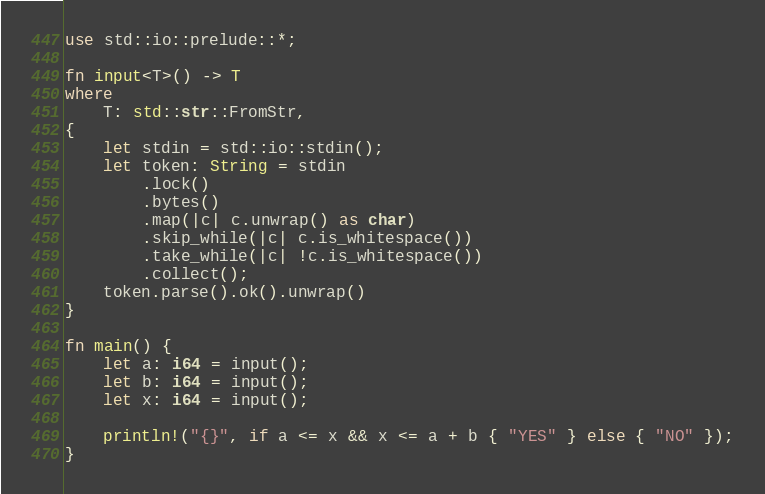<code> <loc_0><loc_0><loc_500><loc_500><_Rust_>use std::io::prelude::*;

fn input<T>() -> T
where
    T: std::str::FromStr,
{
    let stdin = std::io::stdin();
    let token: String = stdin
        .lock()
        .bytes()
        .map(|c| c.unwrap() as char)
        .skip_while(|c| c.is_whitespace())
        .take_while(|c| !c.is_whitespace())
        .collect();
    token.parse().ok().unwrap()
}

fn main() {
    let a: i64 = input();
    let b: i64 = input();
    let x: i64 = input();

    println!("{}", if a <= x && x <= a + b { "YES" } else { "NO" });
}
</code> 